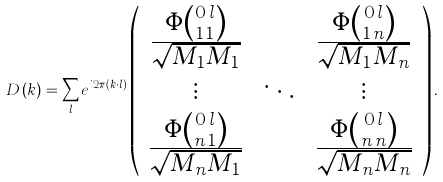Convert formula to latex. <formula><loc_0><loc_0><loc_500><loc_500>D \left ( k \right ) = \sum _ { l } e ^ { i 2 \pi \left ( k \cdot l \right ) } \left ( \begin{array} { c c c } \frac { \Phi \binom { 0 \, l } { 1 \, 1 } } { \sqrt { M _ { 1 } M _ { 1 } } } & \cdots & \frac { \Phi \binom { 0 \, l } { 1 \, n } } { \sqrt { M _ { 1 } M _ { n } } } \\ \vdots & \ddots & \vdots \\ \frac { \Phi \binom { 0 \, l } { n \, 1 } } { \sqrt { M _ { n } M _ { 1 } } } & \cdots & \frac { \Phi \binom { 0 \, l } { n \, n } } { \sqrt { M _ { n } M _ { n } } } \end{array} \right ) .</formula> 